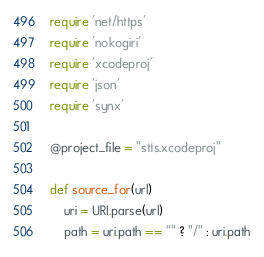Convert code to text. <code><loc_0><loc_0><loc_500><loc_500><_Ruby_>require 'net/https'
require 'nokogiri'
require 'xcodeproj'
require 'json'
require 'synx'

@project_file = "stts.xcodeproj"

def source_for(url)
    uri = URI.parse(url)
    path = uri.path == "" ? "/" : uri.path</code> 